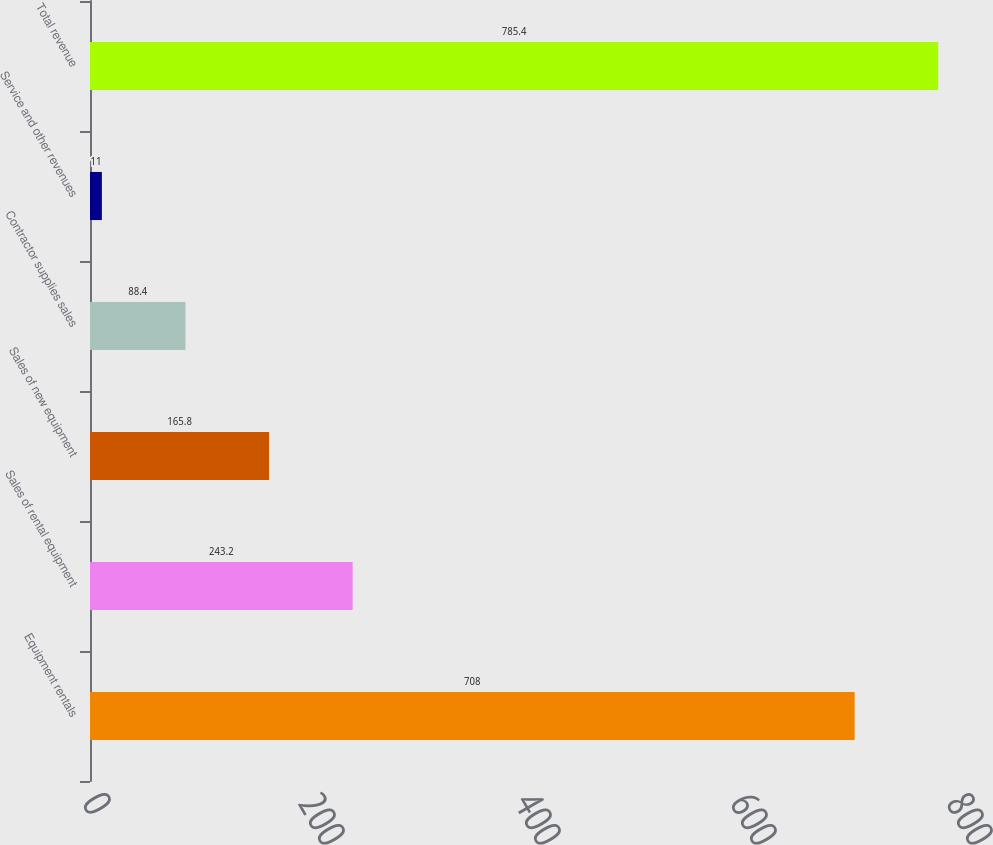Convert chart to OTSL. <chart><loc_0><loc_0><loc_500><loc_500><bar_chart><fcel>Equipment rentals<fcel>Sales of rental equipment<fcel>Sales of new equipment<fcel>Contractor supplies sales<fcel>Service and other revenues<fcel>Total revenue<nl><fcel>708<fcel>243.2<fcel>165.8<fcel>88.4<fcel>11<fcel>785.4<nl></chart> 